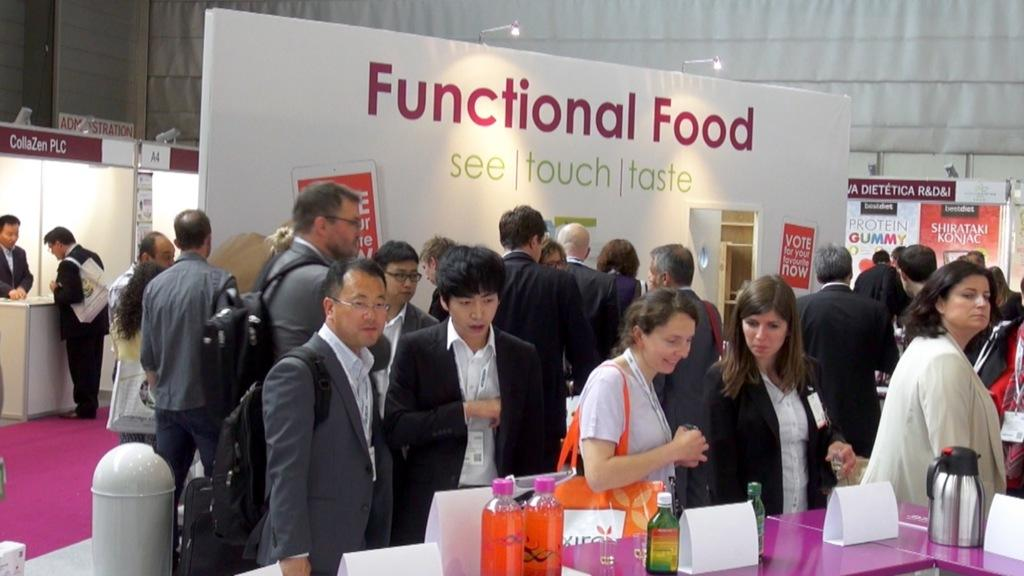What can be seen in the image involving people? There are people standing in the image. What type of objects with text are present in the image? There are boards with text in the image. What other items can be seen in the image? There are bottles and a kettle in the image. What is on the table in the image? There are name boards on a table in the image. What can be seen in the image that provides illumination? There are lights visible in the image. What is the name of the daughter of the person standing on the left in the image? There is no information about the people's names or their family relationships in the image; it only features people, boards with text, bottles, a kettle, name boards on a table, and lights. 